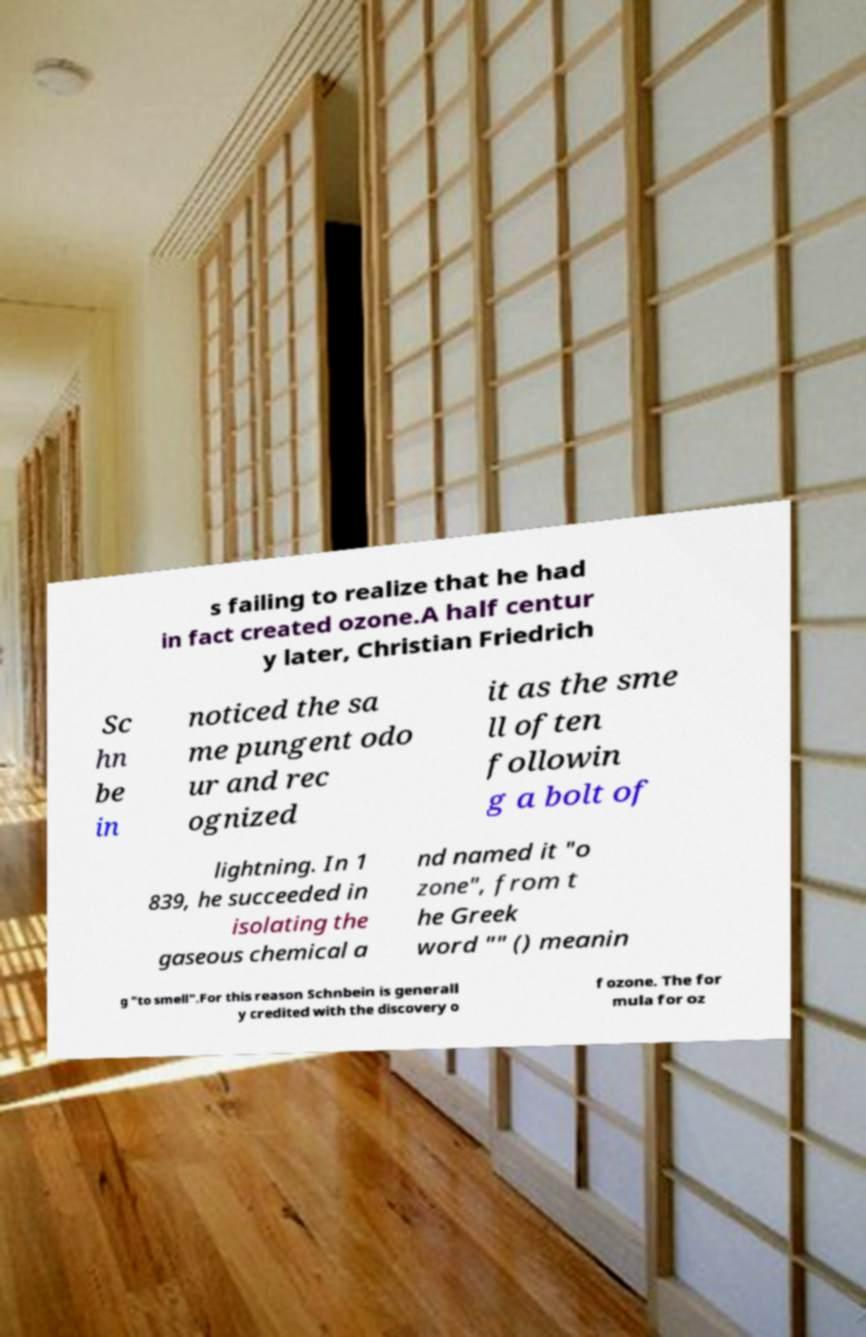Could you extract and type out the text from this image? s failing to realize that he had in fact created ozone.A half centur y later, Christian Friedrich Sc hn be in noticed the sa me pungent odo ur and rec ognized it as the sme ll often followin g a bolt of lightning. In 1 839, he succeeded in isolating the gaseous chemical a nd named it "o zone", from t he Greek word "" () meanin g "to smell".For this reason Schnbein is generall y credited with the discovery o f ozone. The for mula for oz 